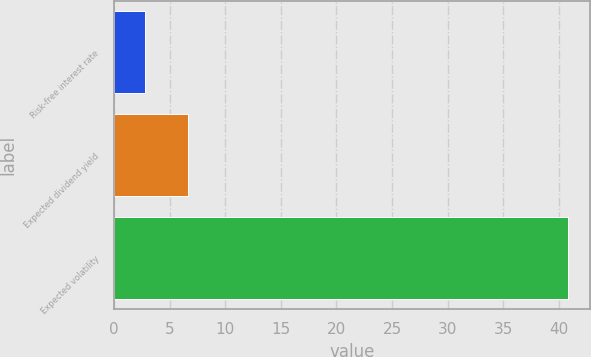<chart> <loc_0><loc_0><loc_500><loc_500><bar_chart><fcel>Risk-free interest rate<fcel>Expected dividend yield<fcel>Expected volatility<nl><fcel>2.8<fcel>6.6<fcel>40.8<nl></chart> 